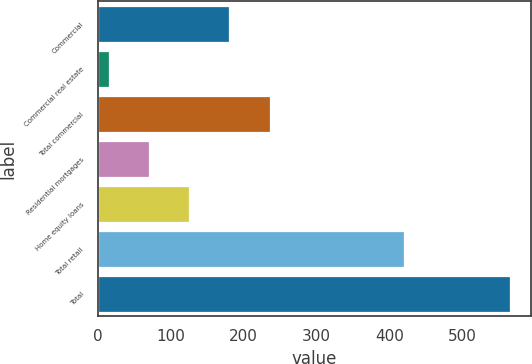<chart> <loc_0><loc_0><loc_500><loc_500><bar_chart><fcel>Commercial<fcel>Commercial real estate<fcel>Total commercial<fcel>Residential mortgages<fcel>Home equity loans<fcel>Total retail<fcel>Total<nl><fcel>180.3<fcel>15<fcel>235.4<fcel>70.1<fcel>125.2<fcel>420<fcel>566<nl></chart> 